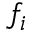<formula> <loc_0><loc_0><loc_500><loc_500>f _ { i }</formula> 